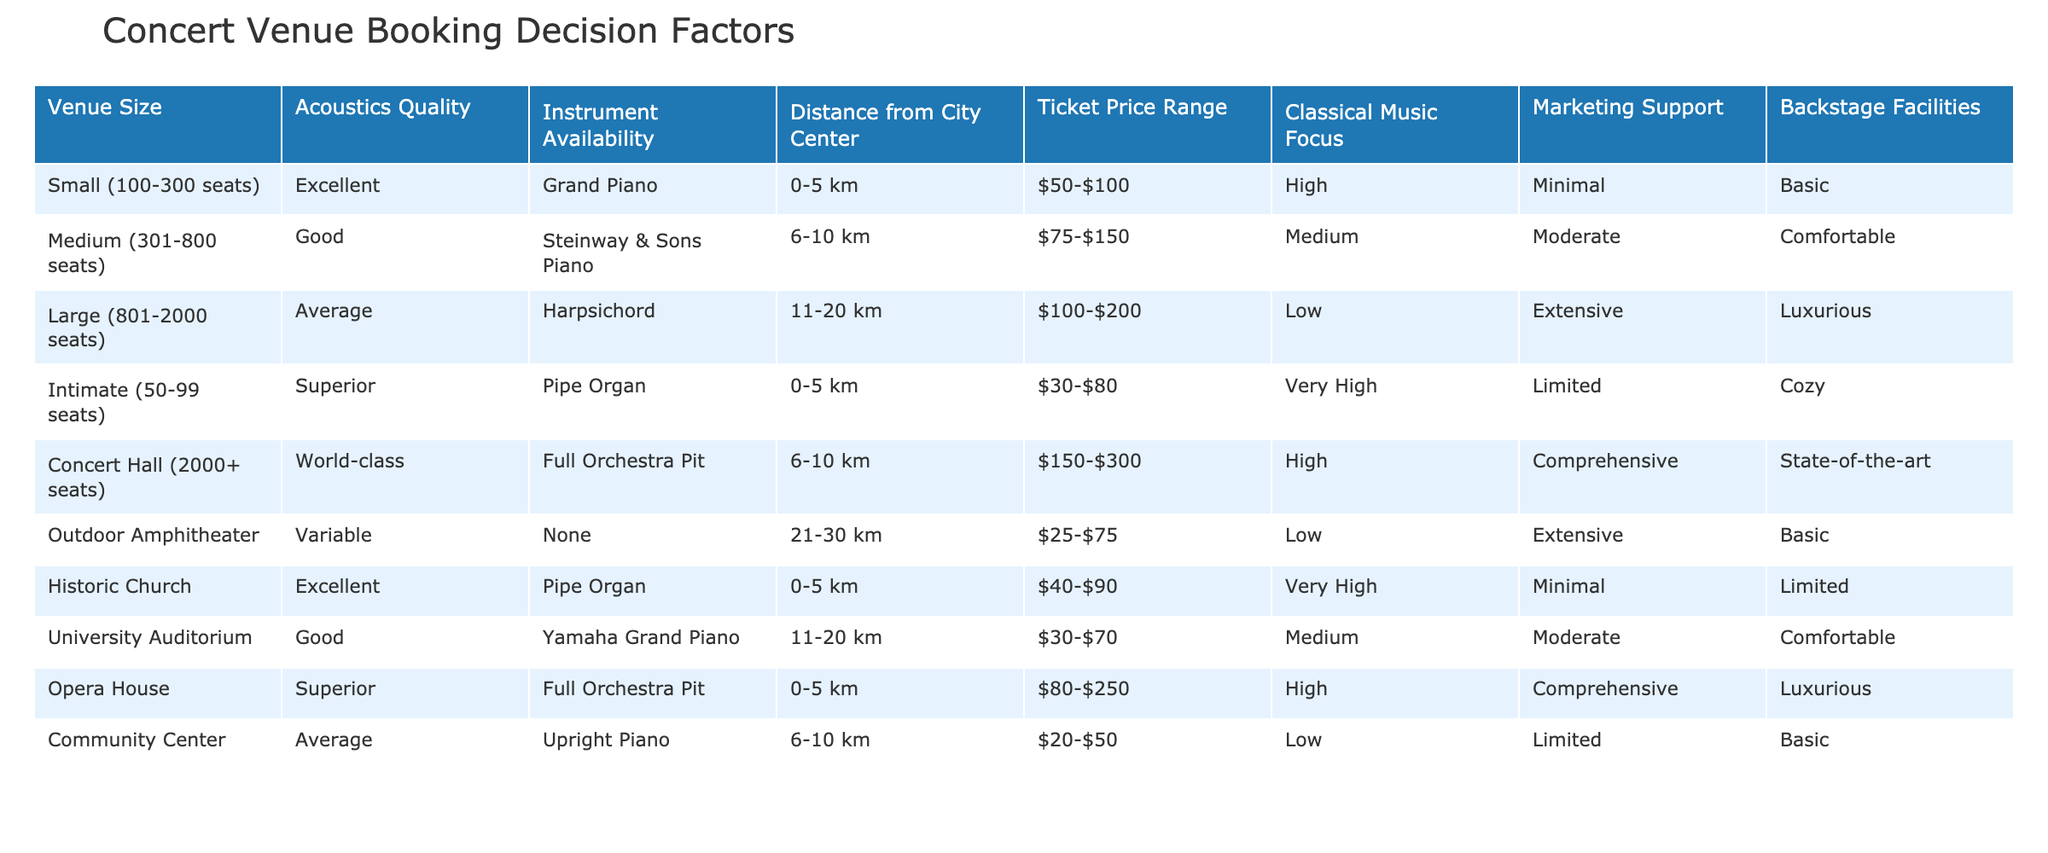What is the capacity of the Concert Hall? The Concert Hall is listed in the table with the venue size category of "2000+ seats," which indicates its capacity.
Answer: 2000+ seats Which venue has the best acoustics quality? The best acoustics quality listed in the table is "World-class," which is associated with the Concert Hall.
Answer: Concert Hall How many venues have a focus on classical music? By reviewing the table, we can count the venues with high or very high focus on classical music: Intimate, Historic Church, Opera House, and Concert Hall. This gives us four venues in total.
Answer: 4 What is the average ticket price range for venues with extensive marketing support? The venues that offer extensive marketing support are the Large venue and the Concert Hall, with ticket price ranges of $100-$200 and $150-$300, respectively. Calculating their average: ($100 + 200 + 150 + 300) / 4 = $187.5, so the average ticket price range is approximately $187.5.
Answer: Approximately $187.5 Is the Historic Church closer to the city center than the Medium venue? The Historic Church is located 0-5 km from the city center, while the Medium venue is located 6-10 km away. Since 0-5 km is less than 6-10 km, we conclude that the Historic Church is indeed closer to the city center.
Answer: Yes What is the difference in seating capacity between the Large venue and the Community Center? The Large venue has a seating capacity of 801-2000, and the Community Center has a seating capacity of 100-300. The difference requires comparing the maximum values: 2000 - 300 equals 1700. Thus, the difference in their maximum seating capacity is 1700 seats.
Answer: 1700 seats Are there any venues that focus solely on classical music? We notice that the venues with a "very high" or "high" focus on classical music include the Intimate, Historic Church, Opera House, and the Concert Hall. Therefore, there are venues that emphasize classical music, but there is no venue that focuses solely on it since none of them are labeled as "solely."
Answer: No Which venue has the most luxurious backstage facilities? In the table, there are two venues with luxurious backstage facilities: the Concert Hall and the Opera House, both of which are categorized as "State-of-the-art" and "Luxurious." However, the Concert Hall is explicitly categorized as "state-of-the-art," which is typically considered more luxurious in quality.
Answer: Concert Hall 